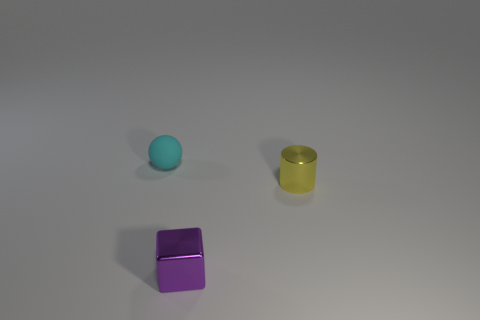There is a cyan ball; does it have the same size as the metal thing to the right of the tiny metallic block?
Offer a very short reply. Yes. The object that is both on the right side of the tiny matte object and to the left of the yellow metallic cylinder is what color?
Give a very brief answer. Purple. What number of other objects are the same shape as the small rubber thing?
Provide a succinct answer. 0. Does the metallic thing behind the small purple thing have the same color as the small thing that is to the left of the block?
Keep it short and to the point. No. There is a thing that is to the right of the purple shiny thing; does it have the same size as the thing left of the purple shiny cube?
Offer a very short reply. Yes. Is there anything else that is the same material as the cube?
Keep it short and to the point. Yes. There is a thing that is in front of the tiny shiny object behind the small metallic thing that is on the left side of the yellow shiny cylinder; what is it made of?
Your answer should be very brief. Metal. Does the purple metal thing have the same shape as the tiny yellow object?
Give a very brief answer. No. How many shiny objects have the same color as the rubber ball?
Ensure brevity in your answer.  0. What is the size of the purple cube that is the same material as the cylinder?
Provide a succinct answer. Small. 